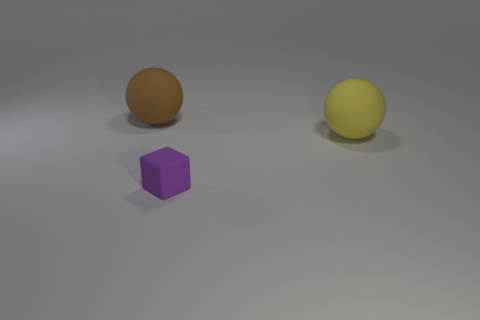There is a brown object; is its shape the same as the large rubber object that is on the right side of the tiny rubber cube?
Your response must be concise. Yes. Is there anything else that has the same size as the cube?
Make the answer very short. No. What is the size of the yellow rubber object that is the same shape as the big brown thing?
Your answer should be compact. Large. Is the number of tiny things greater than the number of yellow shiny things?
Give a very brief answer. Yes. Is the shape of the purple thing the same as the large brown rubber thing?
Your answer should be very brief. No. The ball left of the big thing right of the brown rubber thing is made of what material?
Provide a short and direct response. Rubber. Is the yellow sphere the same size as the brown sphere?
Make the answer very short. Yes. Is there a large matte ball that is on the left side of the ball that is on the left side of the matte cube?
Offer a very short reply. No. What is the shape of the large matte thing behind the big yellow matte ball?
Provide a succinct answer. Sphere. There is a rubber object in front of the matte object to the right of the small purple object; what number of large yellow rubber things are on the right side of it?
Ensure brevity in your answer.  1. 